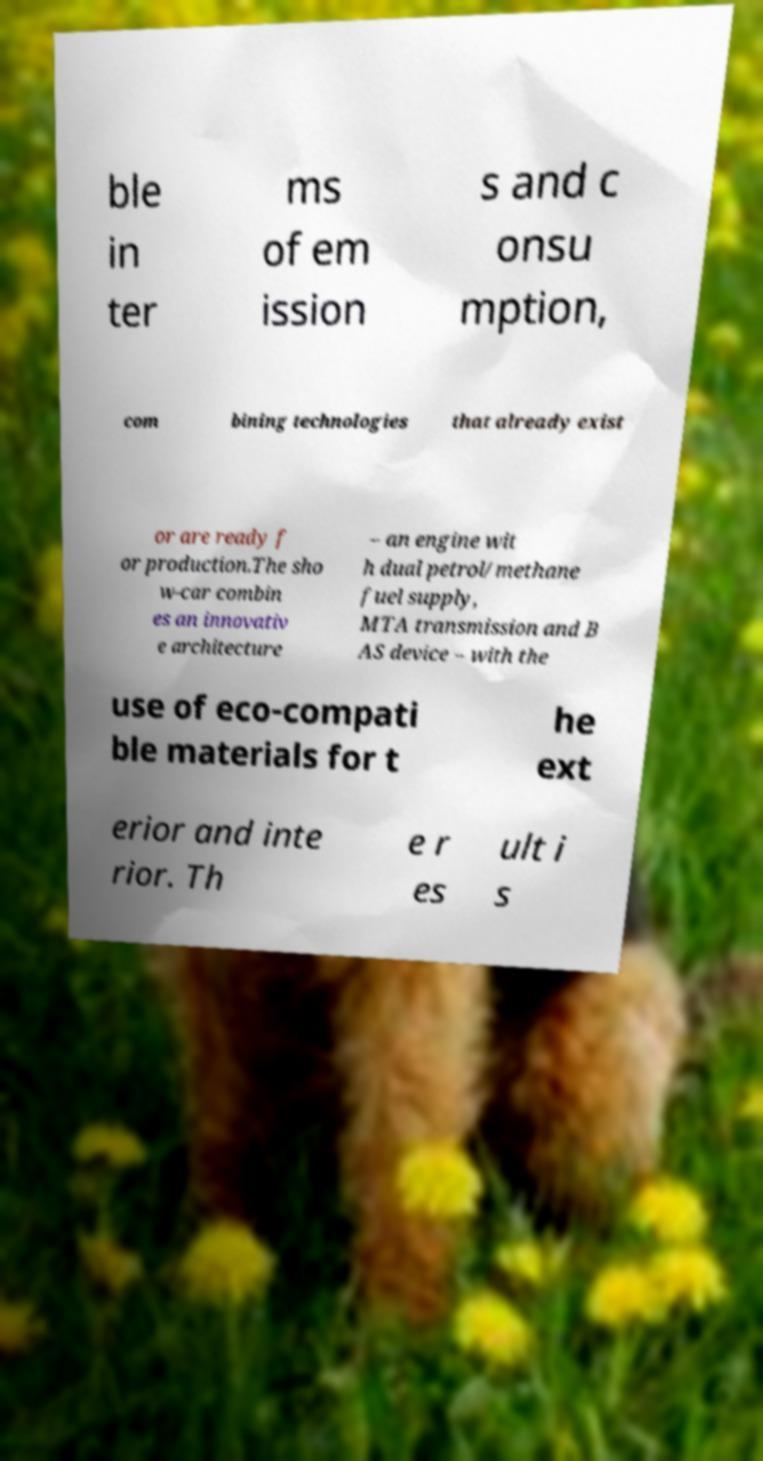Please identify and transcribe the text found in this image. ble in ter ms of em ission s and c onsu mption, com bining technologies that already exist or are ready f or production.The sho w-car combin es an innovativ e architecture – an engine wit h dual petrol/methane fuel supply, MTA transmission and B AS device – with the use of eco-compati ble materials for t he ext erior and inte rior. Th e r es ult i s 